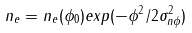<formula> <loc_0><loc_0><loc_500><loc_500>n _ { e } = n _ { e } ( \phi _ { 0 } ) e x p ( - \phi ^ { 2 } / 2 \sigma ^ { 2 } _ { n \phi } )</formula> 